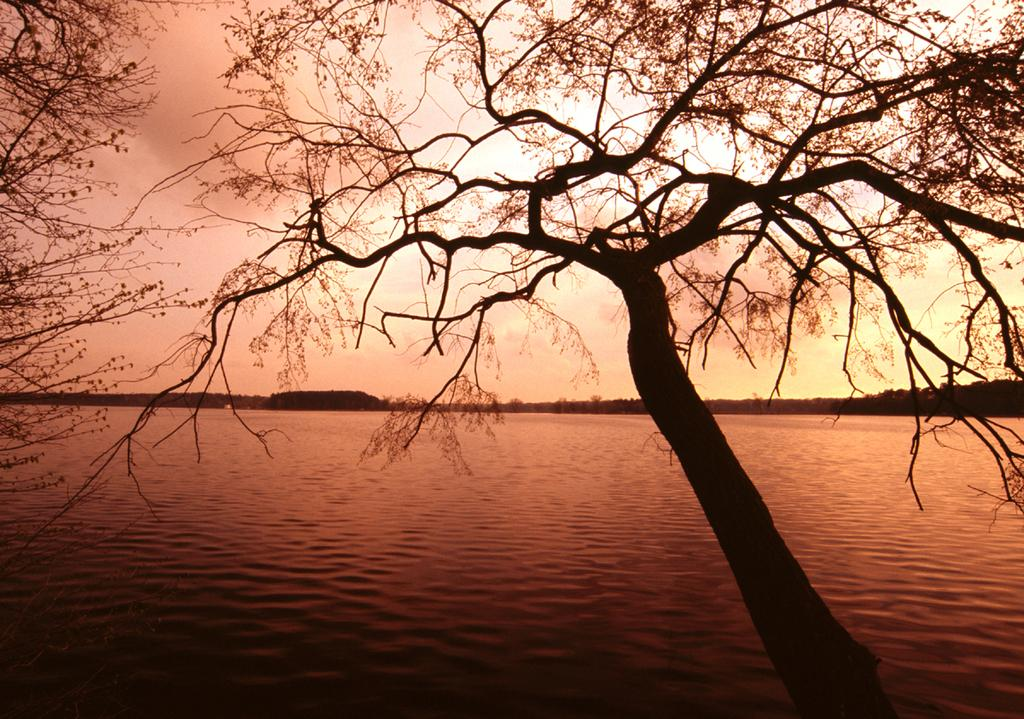What type of vegetation is at the front of the image? There are trees at the front of the image. What natural element is visible in the image? There is water visible in the image. What is visible at the top of the image? The sky is visible at the top of the image. How many borders are visible in the image? There are no borders present in the image. Can you tell me how many times the person in the image sneezes? There is no person present in the image, so it is impossible to determine how many times they sneeze. 